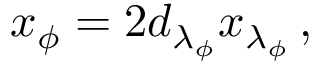<formula> <loc_0><loc_0><loc_500><loc_500>x _ { \phi } = 2 d _ { \lambda _ { \phi } } x _ { \lambda _ { \phi } } \, ,</formula> 